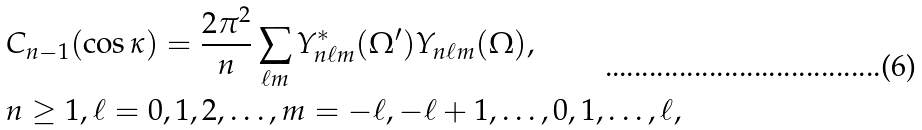Convert formula to latex. <formula><loc_0><loc_0><loc_500><loc_500>& C _ { n - 1 } ( \cos \kappa ) = \frac { 2 \pi ^ { 2 } } n \sum _ { \ell m } Y ^ { * } _ { n \ell m } ( \Omega ^ { \prime } ) Y _ { n \ell m } ( \Omega ) , \\ & n \geq 1 , \ell = 0 , 1 , 2 , \dots , m = - \ell , - \ell + 1 , \dots , 0 , 1 , \dots , \ell ,</formula> 